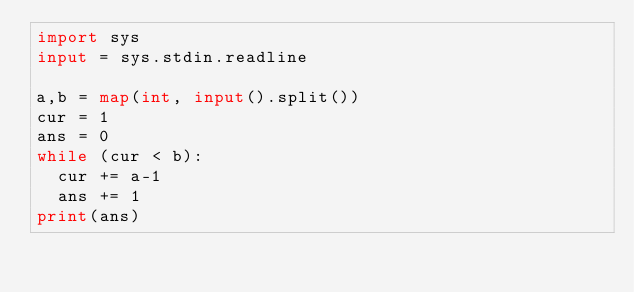Convert code to text. <code><loc_0><loc_0><loc_500><loc_500><_Python_>import sys
input = sys.stdin.readline

a,b = map(int, input().split())
cur = 1
ans = 0
while (cur < b):
	cur += a-1
	ans += 1
print(ans)
</code> 